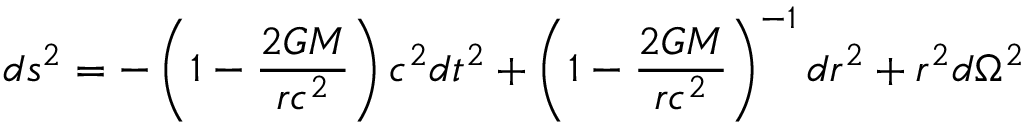Convert formula to latex. <formula><loc_0><loc_0><loc_500><loc_500>d s ^ { 2 } = - \left ( 1 - { \frac { 2 G M } { r c ^ { 2 } } } \right ) c ^ { 2 } d t ^ { 2 } + \left ( 1 - { \frac { 2 G M } { r c ^ { 2 } } } \right ) ^ { - 1 } d r ^ { 2 } + r ^ { 2 } d \Omega ^ { 2 }</formula> 